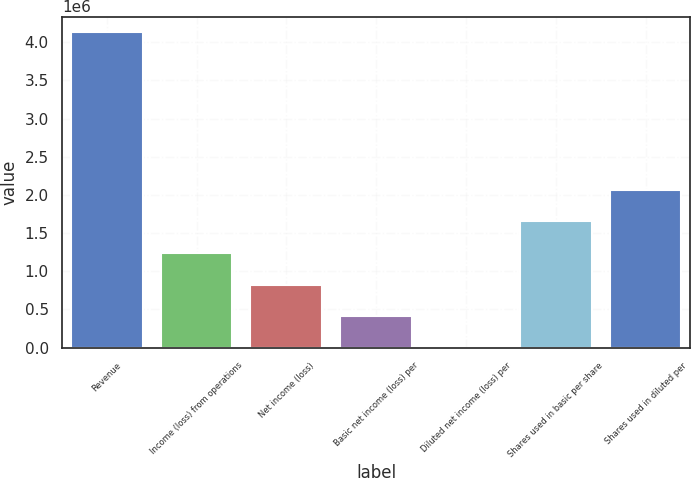Convert chart to OTSL. <chart><loc_0><loc_0><loc_500><loc_500><bar_chart><fcel>Revenue<fcel>Income (loss) from operations<fcel>Net income (loss)<fcel>Basic net income (loss) per<fcel>Diluted net income (loss) per<fcel>Shares used in basic per share<fcel>Shares used in diluted per<nl><fcel>4.13016e+06<fcel>1.23905e+06<fcel>826033<fcel>413017<fcel>0.74<fcel>1.65207e+06<fcel>2.06508e+06<nl></chart> 